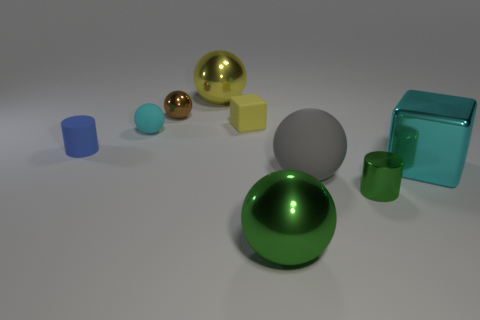How many metallic objects are on the right side of the small brown shiny sphere and in front of the big yellow object?
Give a very brief answer. 3. How many other objects are there of the same size as the metallic cylinder?
Your response must be concise. 4. The large object that is right of the green shiny sphere and left of the cyan shiny thing is made of what material?
Your response must be concise. Rubber. There is a small rubber cylinder; does it have the same color as the rubber sphere left of the big green metallic sphere?
Give a very brief answer. No. There is a green thing that is the same shape as the brown object; what is its size?
Your answer should be compact. Large. The big shiny object that is on the left side of the large cyan cube and on the right side of the large yellow sphere has what shape?
Make the answer very short. Sphere. Does the yellow metallic thing have the same size as the cylinder that is in front of the blue cylinder?
Make the answer very short. No. There is a tiny shiny thing that is the same shape as the large yellow metal thing; what is its color?
Provide a succinct answer. Brown. There is a cylinder that is in front of the cyan shiny block; is its size the same as the rubber object that is in front of the cyan block?
Your answer should be very brief. No. Does the small brown thing have the same shape as the gray matte thing?
Your response must be concise. Yes. 